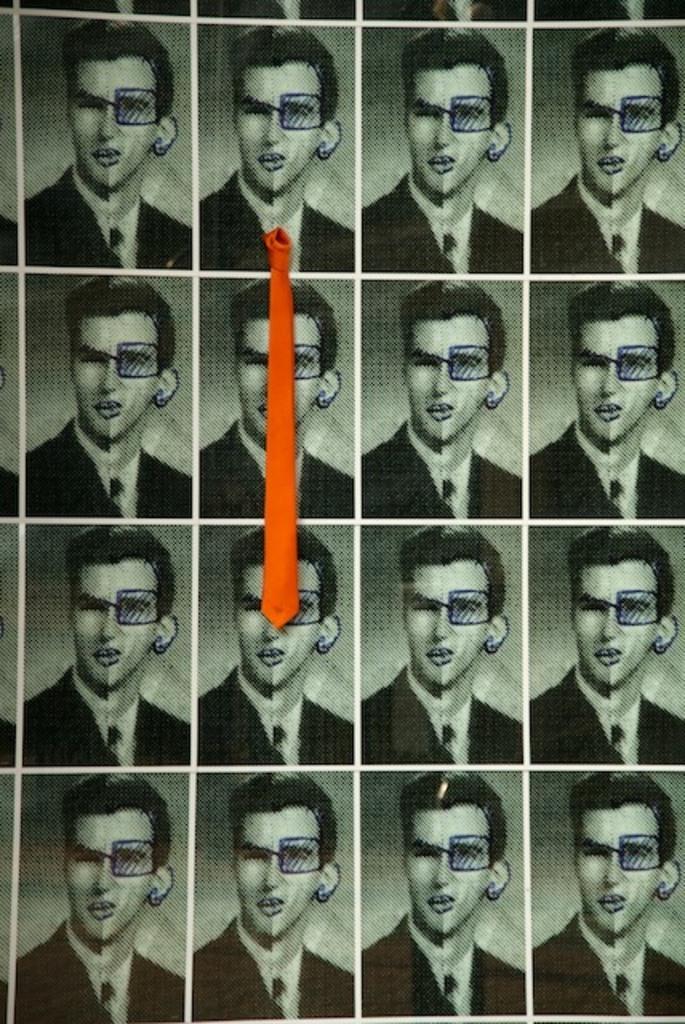Describe this image in one or two sentences. In this image we can see images of a person on the paper and there is a tie. 